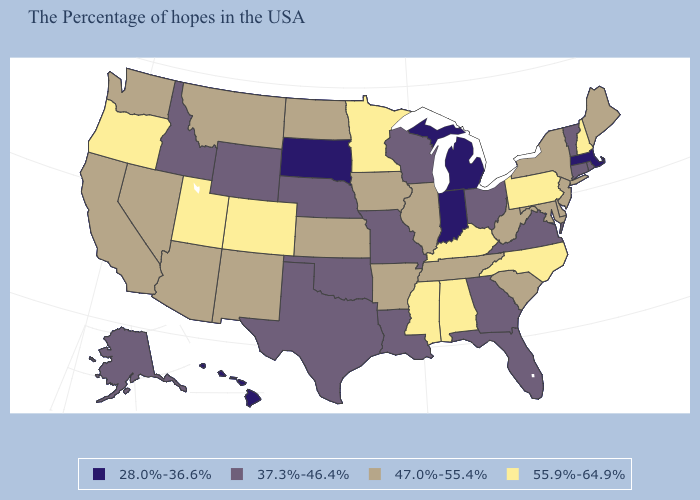What is the highest value in the Northeast ?
Answer briefly. 55.9%-64.9%. Among the states that border Delaware , does Maryland have the lowest value?
Write a very short answer. Yes. What is the value of Idaho?
Write a very short answer. 37.3%-46.4%. Does the first symbol in the legend represent the smallest category?
Be succinct. Yes. Name the states that have a value in the range 37.3%-46.4%?
Quick response, please. Rhode Island, Vermont, Connecticut, Virginia, Ohio, Florida, Georgia, Wisconsin, Louisiana, Missouri, Nebraska, Oklahoma, Texas, Wyoming, Idaho, Alaska. What is the value of New Hampshire?
Answer briefly. 55.9%-64.9%. Does the map have missing data?
Give a very brief answer. No. Name the states that have a value in the range 37.3%-46.4%?
Give a very brief answer. Rhode Island, Vermont, Connecticut, Virginia, Ohio, Florida, Georgia, Wisconsin, Louisiana, Missouri, Nebraska, Oklahoma, Texas, Wyoming, Idaho, Alaska. Name the states that have a value in the range 37.3%-46.4%?
Keep it brief. Rhode Island, Vermont, Connecticut, Virginia, Ohio, Florida, Georgia, Wisconsin, Louisiana, Missouri, Nebraska, Oklahoma, Texas, Wyoming, Idaho, Alaska. What is the highest value in the USA?
Keep it brief. 55.9%-64.9%. Does the map have missing data?
Write a very short answer. No. What is the lowest value in the West?
Quick response, please. 28.0%-36.6%. Does Hawaii have the lowest value in the West?
Answer briefly. Yes. Does Georgia have a higher value than Virginia?
Concise answer only. No. What is the highest value in states that border California?
Quick response, please. 55.9%-64.9%. 